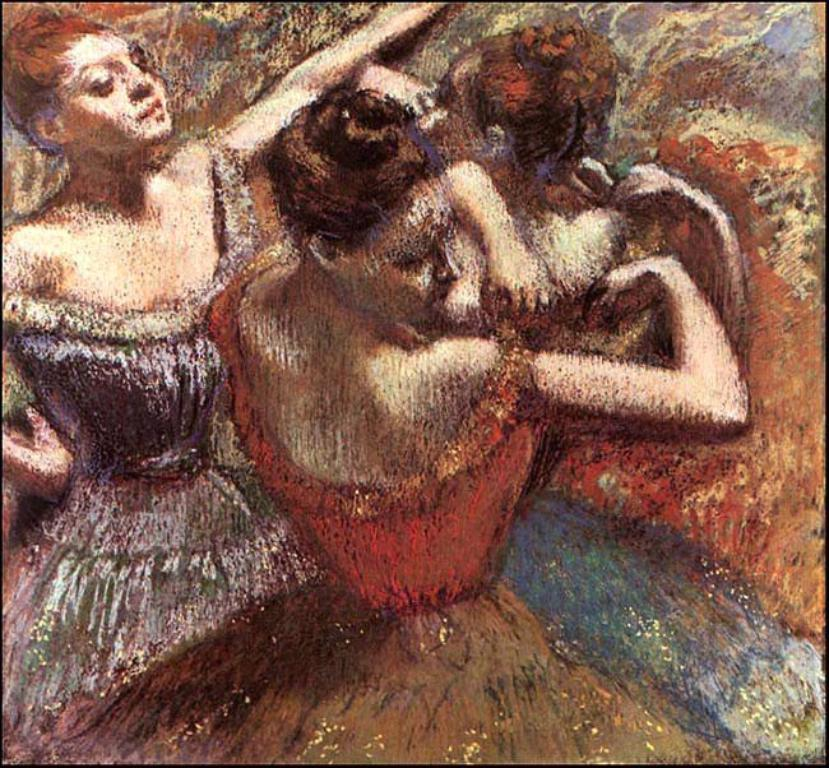What is the main subject of the image? There is a painting in the image. What is happening in the painting? The painting depicts girls dancing. What type of metal is used to create the hospital in the painting? There is no hospital present in the painting; it depicts girls dancing. What is the purpose of the tin object in the painting? There is no tin object present in the painting; it only depicts girls dancing. 